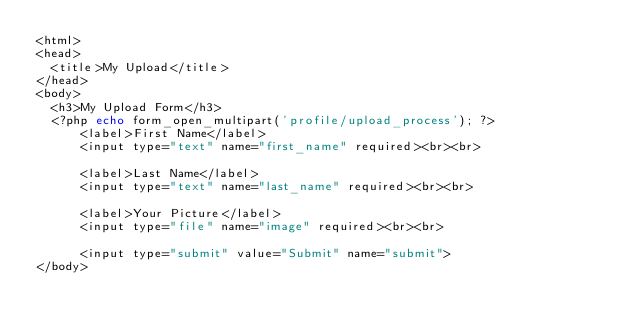<code> <loc_0><loc_0><loc_500><loc_500><_PHP_><html>
<head>
	<title>My Upload</title>
</head>
<body>
	<h3>My Upload Form</h3>
	<?php echo form_open_multipart('profile/upload_process'); ?>
    	<label>First Name</label>
    	<input type="text" name="first_name" required><br><br>

    	<label>Last Name</label>
    	<input type="text" name="last_name" required><br><br>
	
	    <label>Your Picture</label>
	    <input type="file" name="image" required><br><br>
				
  		<input type="submit" value="Submit" name="submit">
</body></code> 